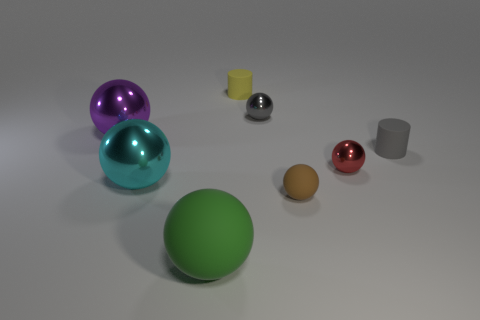Subtract all red balls. How many balls are left? 5 Subtract all large matte balls. How many balls are left? 5 Subtract all yellow balls. Subtract all green blocks. How many balls are left? 6 Add 1 red blocks. How many objects exist? 9 Subtract all balls. How many objects are left? 2 Add 1 gray cylinders. How many gray cylinders are left? 2 Add 5 big objects. How many big objects exist? 8 Subtract 0 red blocks. How many objects are left? 8 Subtract all big green cylinders. Subtract all cylinders. How many objects are left? 6 